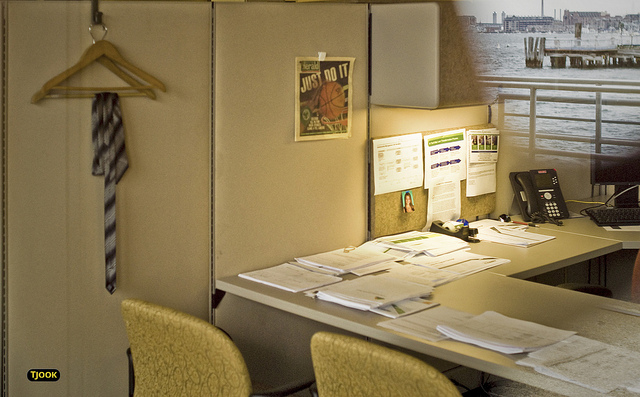Extract all visible text content from this image. NO JUST it TJOOK 